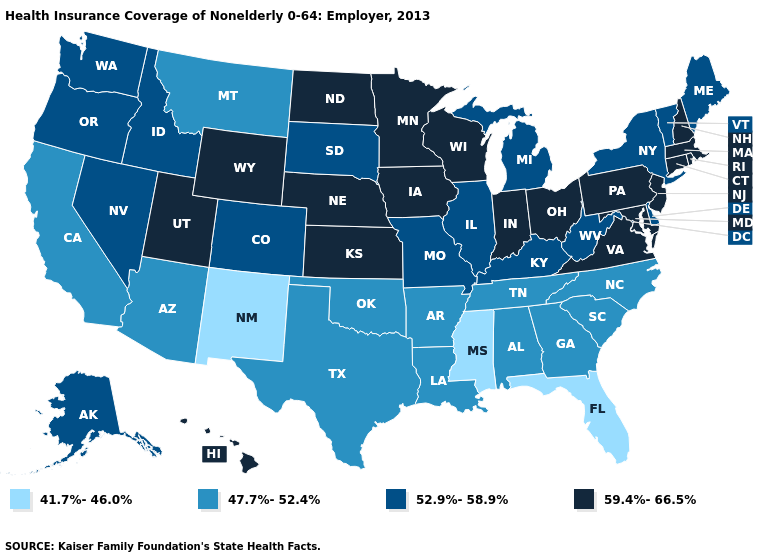Name the states that have a value in the range 59.4%-66.5%?
Give a very brief answer. Connecticut, Hawaii, Indiana, Iowa, Kansas, Maryland, Massachusetts, Minnesota, Nebraska, New Hampshire, New Jersey, North Dakota, Ohio, Pennsylvania, Rhode Island, Utah, Virginia, Wisconsin, Wyoming. Name the states that have a value in the range 52.9%-58.9%?
Give a very brief answer. Alaska, Colorado, Delaware, Idaho, Illinois, Kentucky, Maine, Michigan, Missouri, Nevada, New York, Oregon, South Dakota, Vermont, Washington, West Virginia. Does Vermont have a higher value than North Dakota?
Quick response, please. No. What is the lowest value in the USA?
Keep it brief. 41.7%-46.0%. Does the map have missing data?
Give a very brief answer. No. Which states have the highest value in the USA?
Answer briefly. Connecticut, Hawaii, Indiana, Iowa, Kansas, Maryland, Massachusetts, Minnesota, Nebraska, New Hampshire, New Jersey, North Dakota, Ohio, Pennsylvania, Rhode Island, Utah, Virginia, Wisconsin, Wyoming. Does Florida have the lowest value in the South?
Short answer required. Yes. Does New Mexico have the lowest value in the USA?
Short answer required. Yes. Name the states that have a value in the range 59.4%-66.5%?
Quick response, please. Connecticut, Hawaii, Indiana, Iowa, Kansas, Maryland, Massachusetts, Minnesota, Nebraska, New Hampshire, New Jersey, North Dakota, Ohio, Pennsylvania, Rhode Island, Utah, Virginia, Wisconsin, Wyoming. What is the value of Maine?
Write a very short answer. 52.9%-58.9%. What is the highest value in the Northeast ?
Quick response, please. 59.4%-66.5%. Does Mississippi have the lowest value in the South?
Short answer required. Yes. Name the states that have a value in the range 52.9%-58.9%?
Keep it brief. Alaska, Colorado, Delaware, Idaho, Illinois, Kentucky, Maine, Michigan, Missouri, Nevada, New York, Oregon, South Dakota, Vermont, Washington, West Virginia. Which states have the highest value in the USA?
Give a very brief answer. Connecticut, Hawaii, Indiana, Iowa, Kansas, Maryland, Massachusetts, Minnesota, Nebraska, New Hampshire, New Jersey, North Dakota, Ohio, Pennsylvania, Rhode Island, Utah, Virginia, Wisconsin, Wyoming. Name the states that have a value in the range 41.7%-46.0%?
Quick response, please. Florida, Mississippi, New Mexico. 